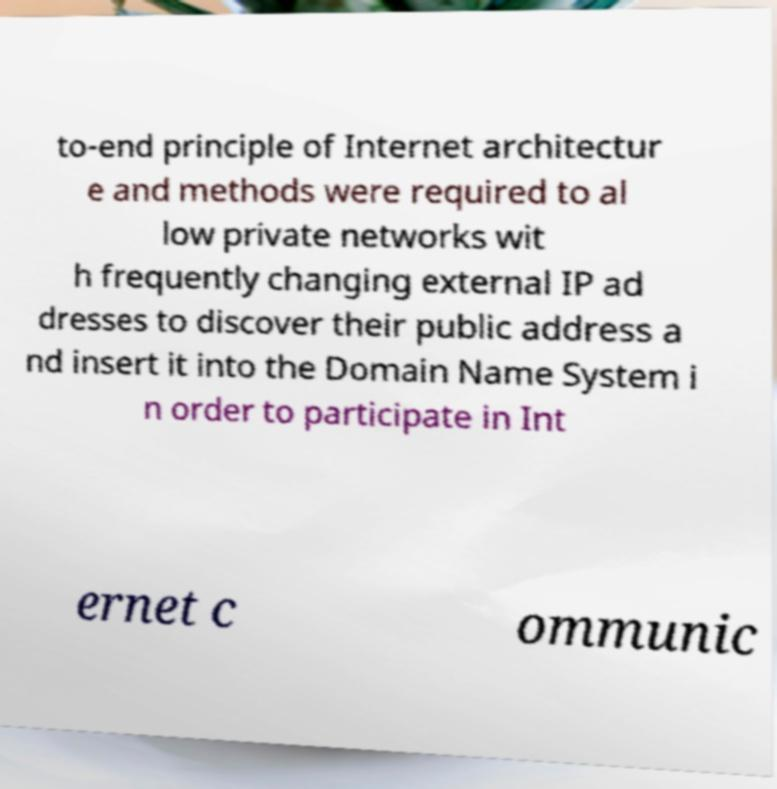There's text embedded in this image that I need extracted. Can you transcribe it verbatim? to-end principle of Internet architectur e and methods were required to al low private networks wit h frequently changing external IP ad dresses to discover their public address a nd insert it into the Domain Name System i n order to participate in Int ernet c ommunic 